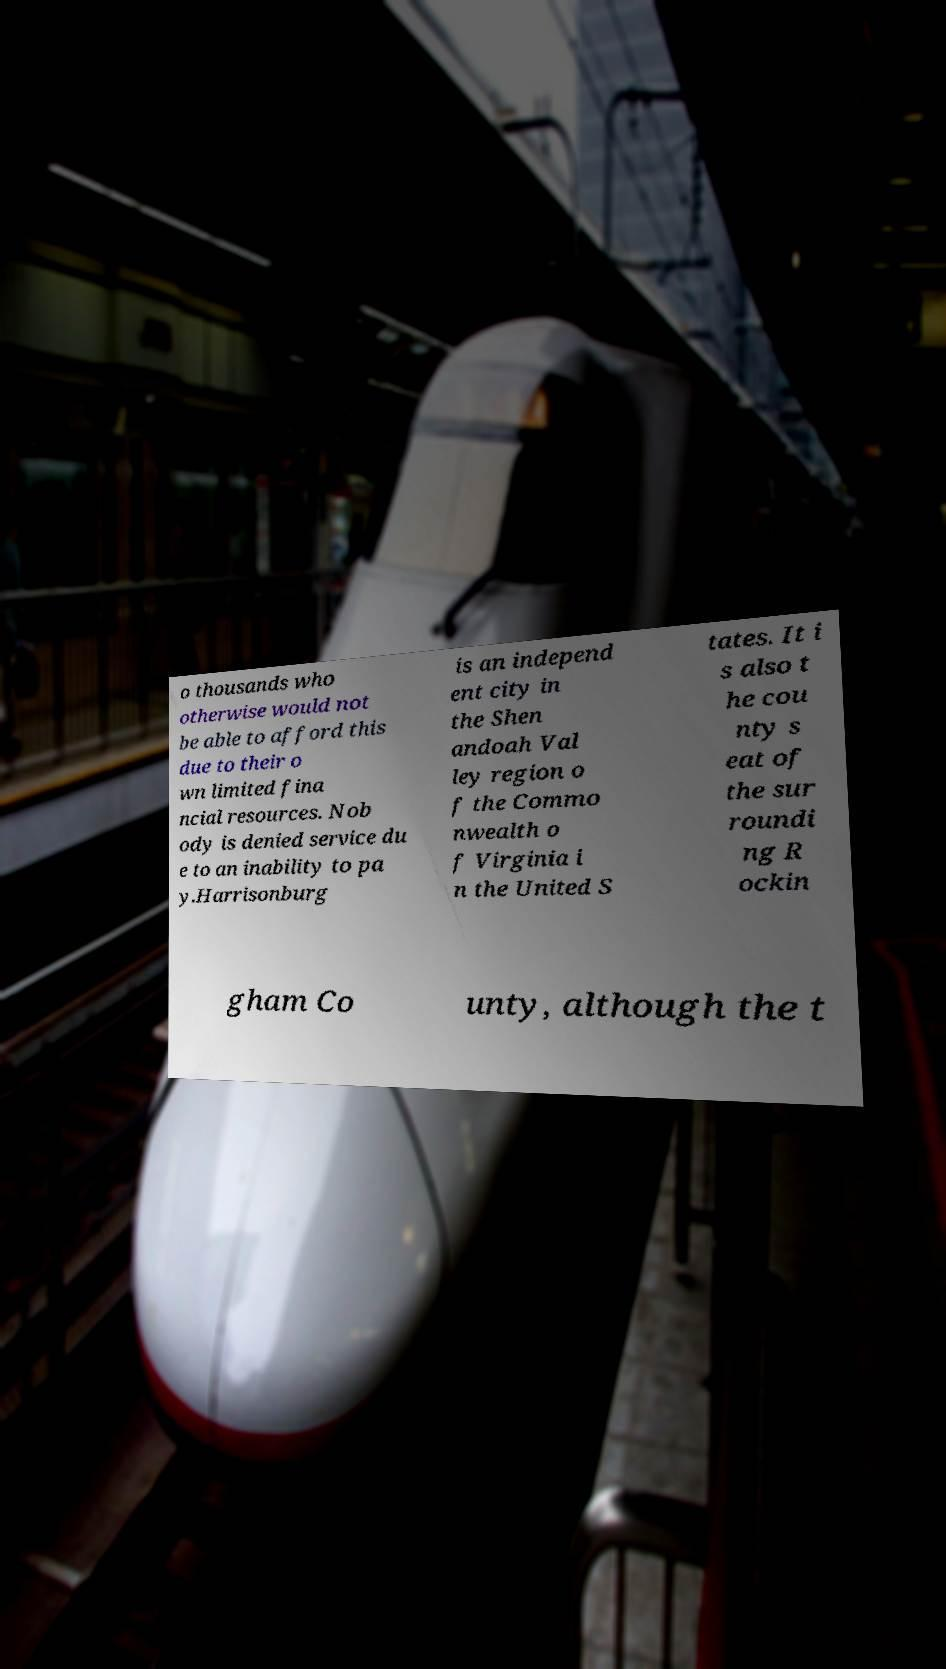There's text embedded in this image that I need extracted. Can you transcribe it verbatim? o thousands who otherwise would not be able to afford this due to their o wn limited fina ncial resources. Nob ody is denied service du e to an inability to pa y.Harrisonburg is an independ ent city in the Shen andoah Val ley region o f the Commo nwealth o f Virginia i n the United S tates. It i s also t he cou nty s eat of the sur roundi ng R ockin gham Co unty, although the t 